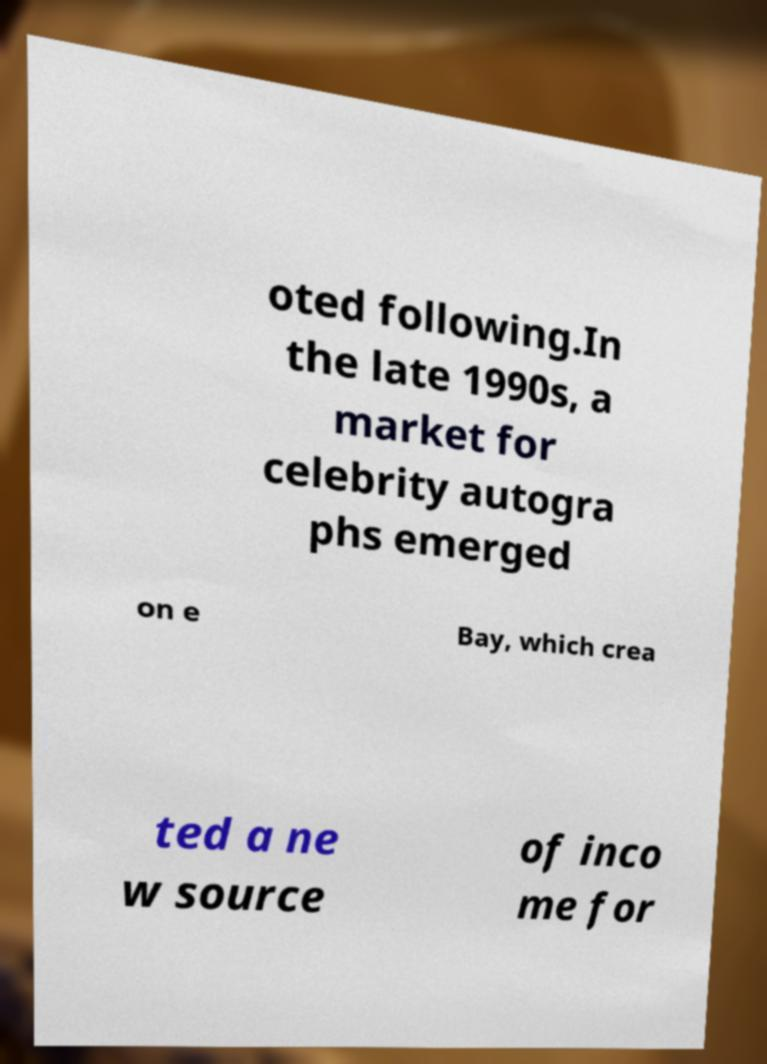Please identify and transcribe the text found in this image. oted following.In the late 1990s, a market for celebrity autogra phs emerged on e Bay, which crea ted a ne w source of inco me for 